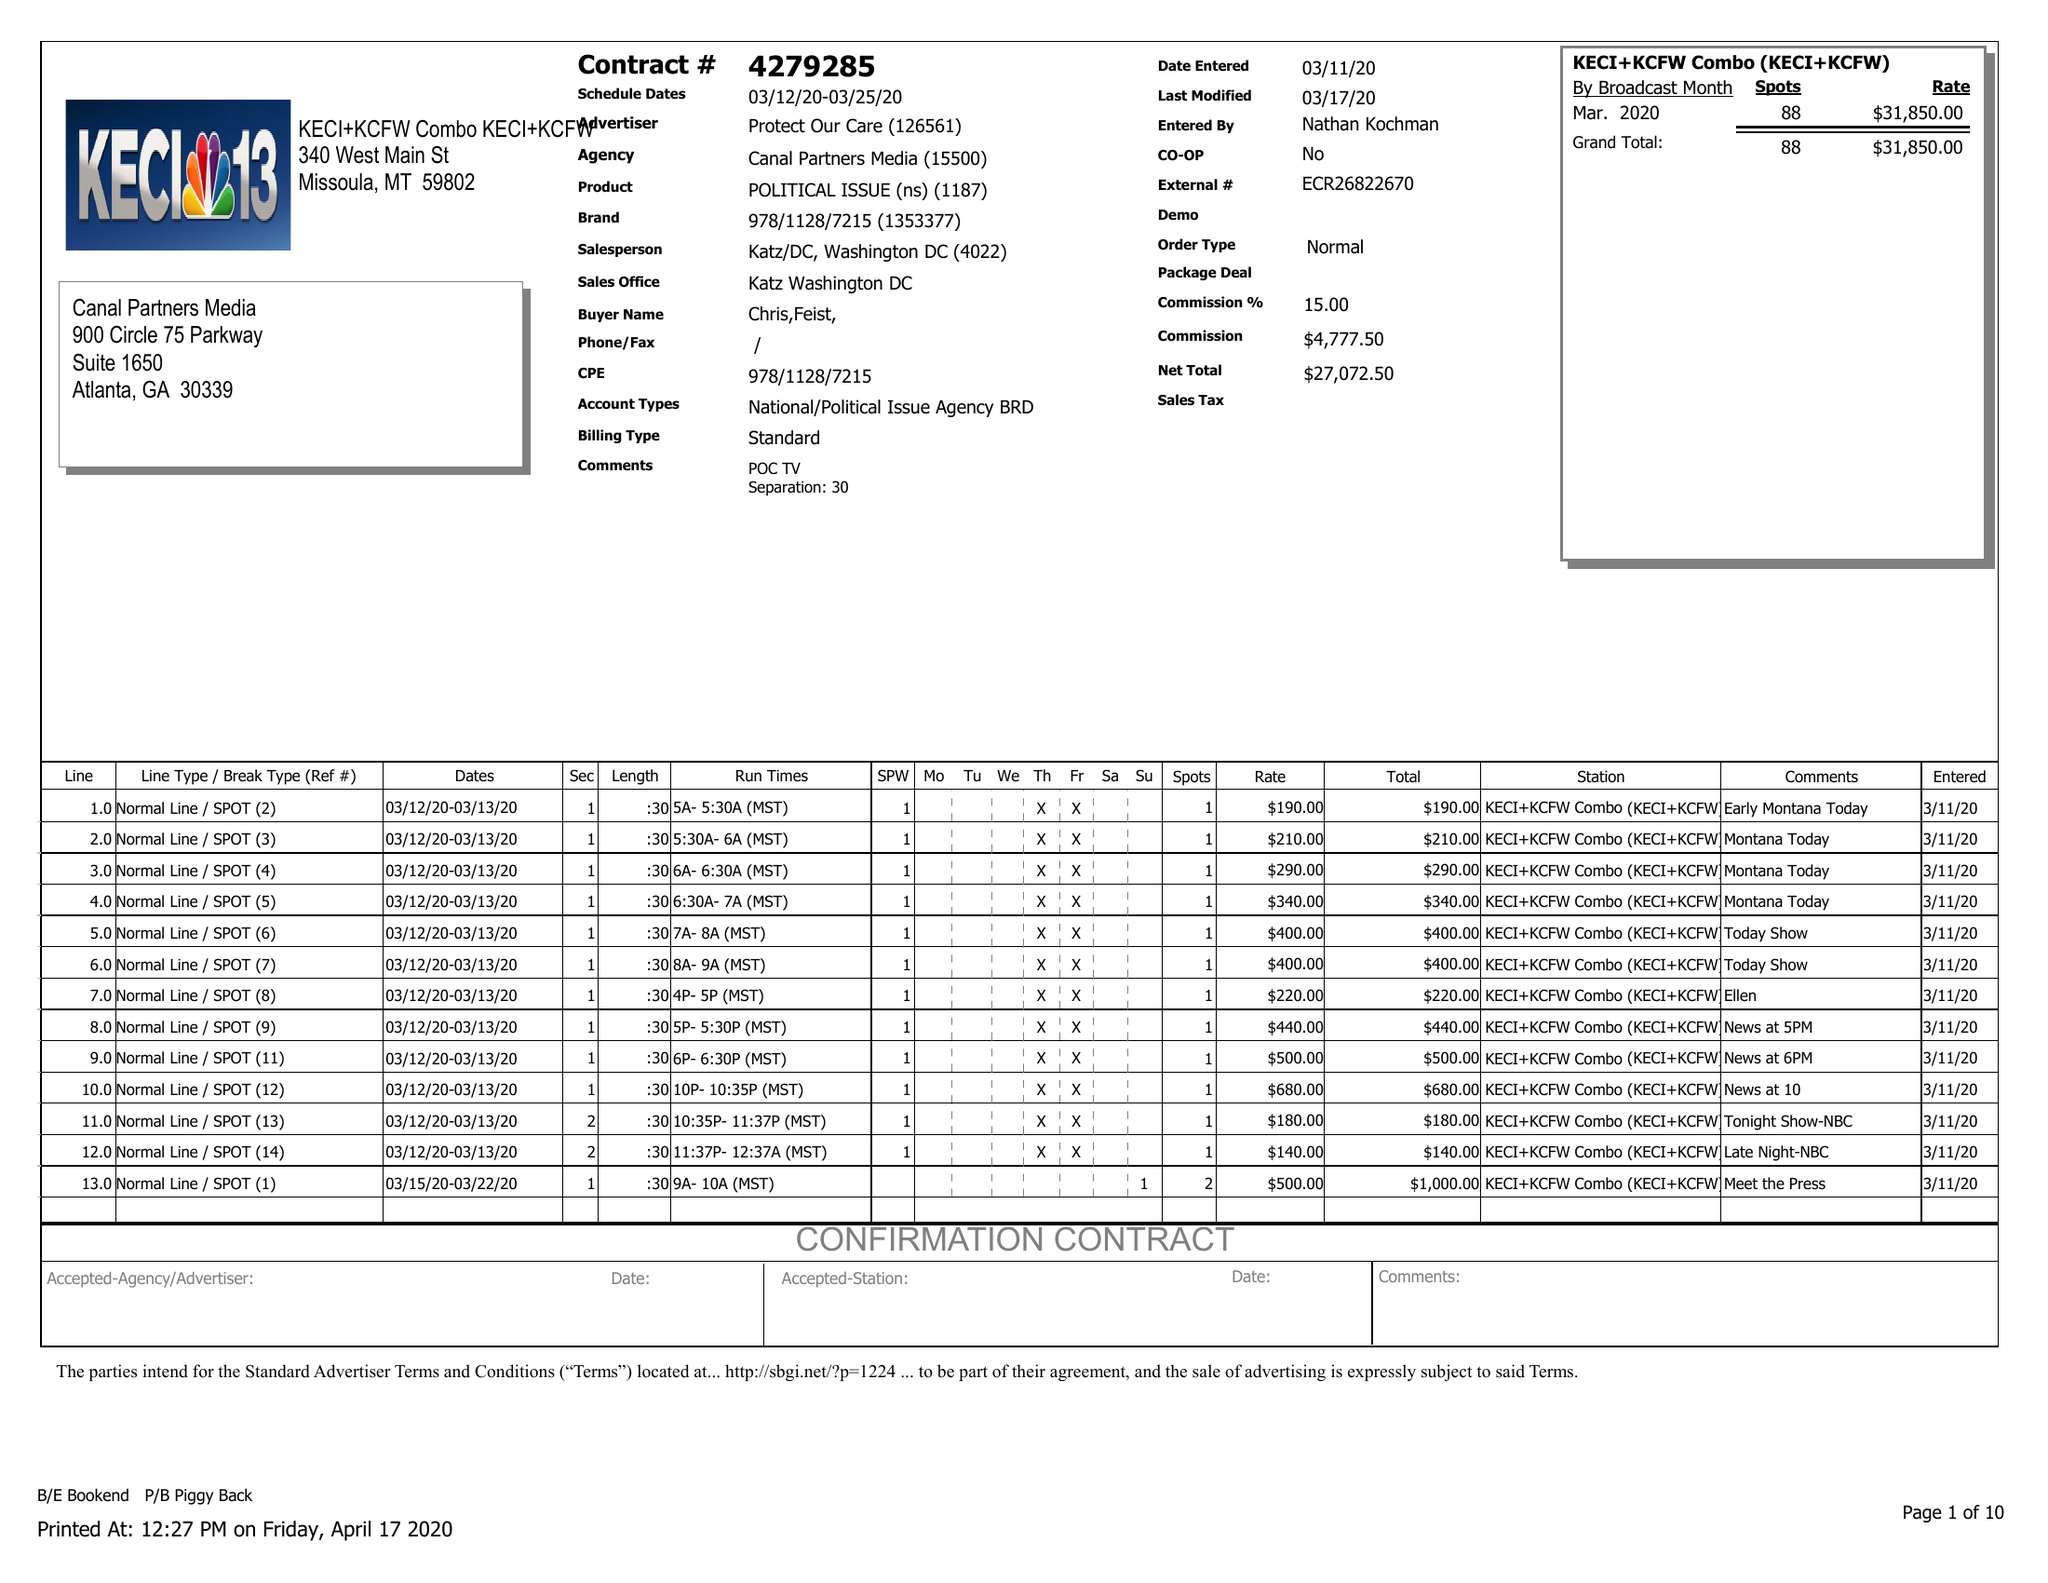What is the value for the contract_num?
Answer the question using a single word or phrase. 4279285 